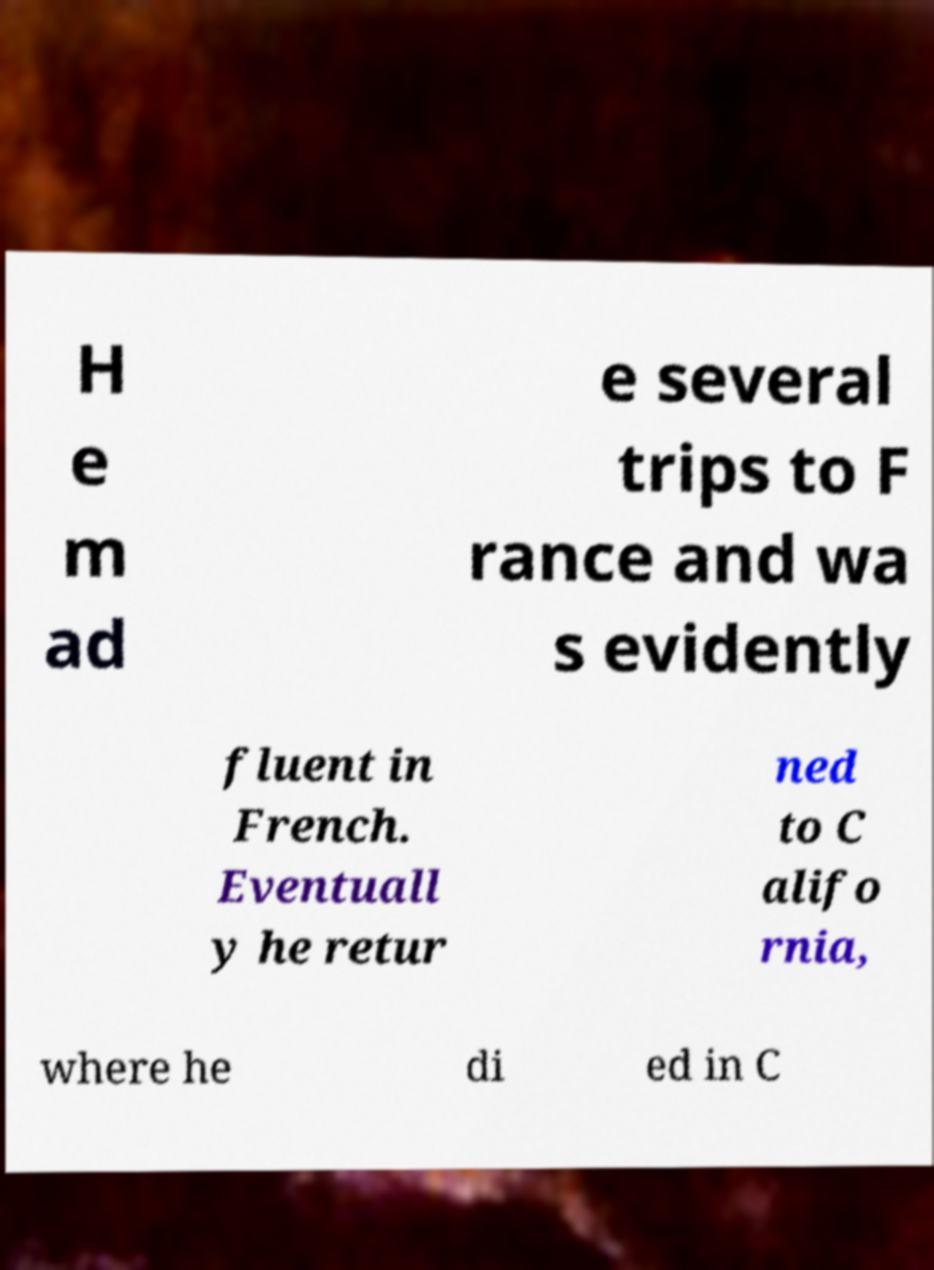Could you extract and type out the text from this image? H e m ad e several trips to F rance and wa s evidently fluent in French. Eventuall y he retur ned to C alifo rnia, where he di ed in C 